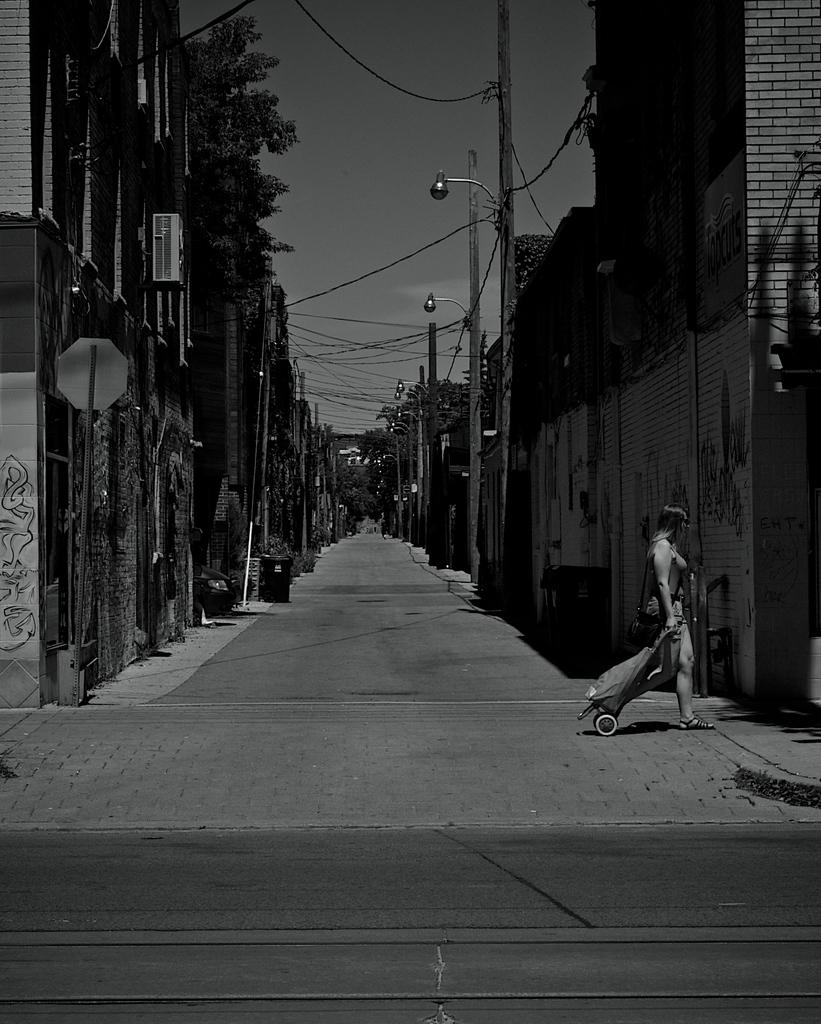What is the main subject of the image? The main subject of the image is an empty road. What is the lady in the image doing? The lady is walking along the road. What is the lady carrying while walking? The lady is carrying a trolley. What can be seen in the background of the image? There are buildings, electric poles, and trees visible in the image. What type of crown is the lady wearing in the image? There is no crown visible in the image; the lady is not wearing any headgear. Can you tell me how many parents are accompanying the lady in the image? There is no indication of any parents accompanying the lady in the image; she is walking alone. 